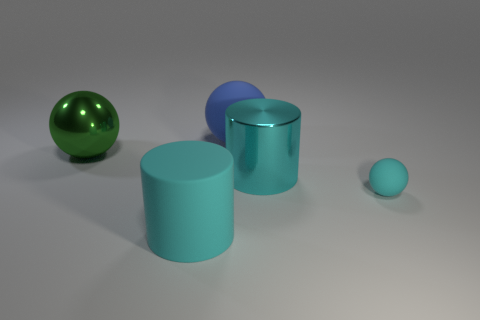Add 4 tiny balls. How many objects exist? 9 Subtract all cylinders. How many objects are left? 3 Add 2 green shiny things. How many green shiny things are left? 3 Add 3 small yellow blocks. How many small yellow blocks exist? 3 Subtract 0 green cubes. How many objects are left? 5 Subtract all shiny cylinders. Subtract all metallic things. How many objects are left? 2 